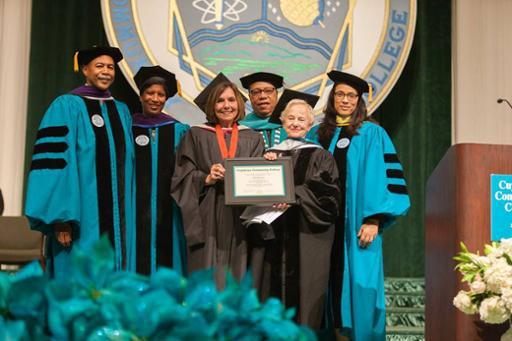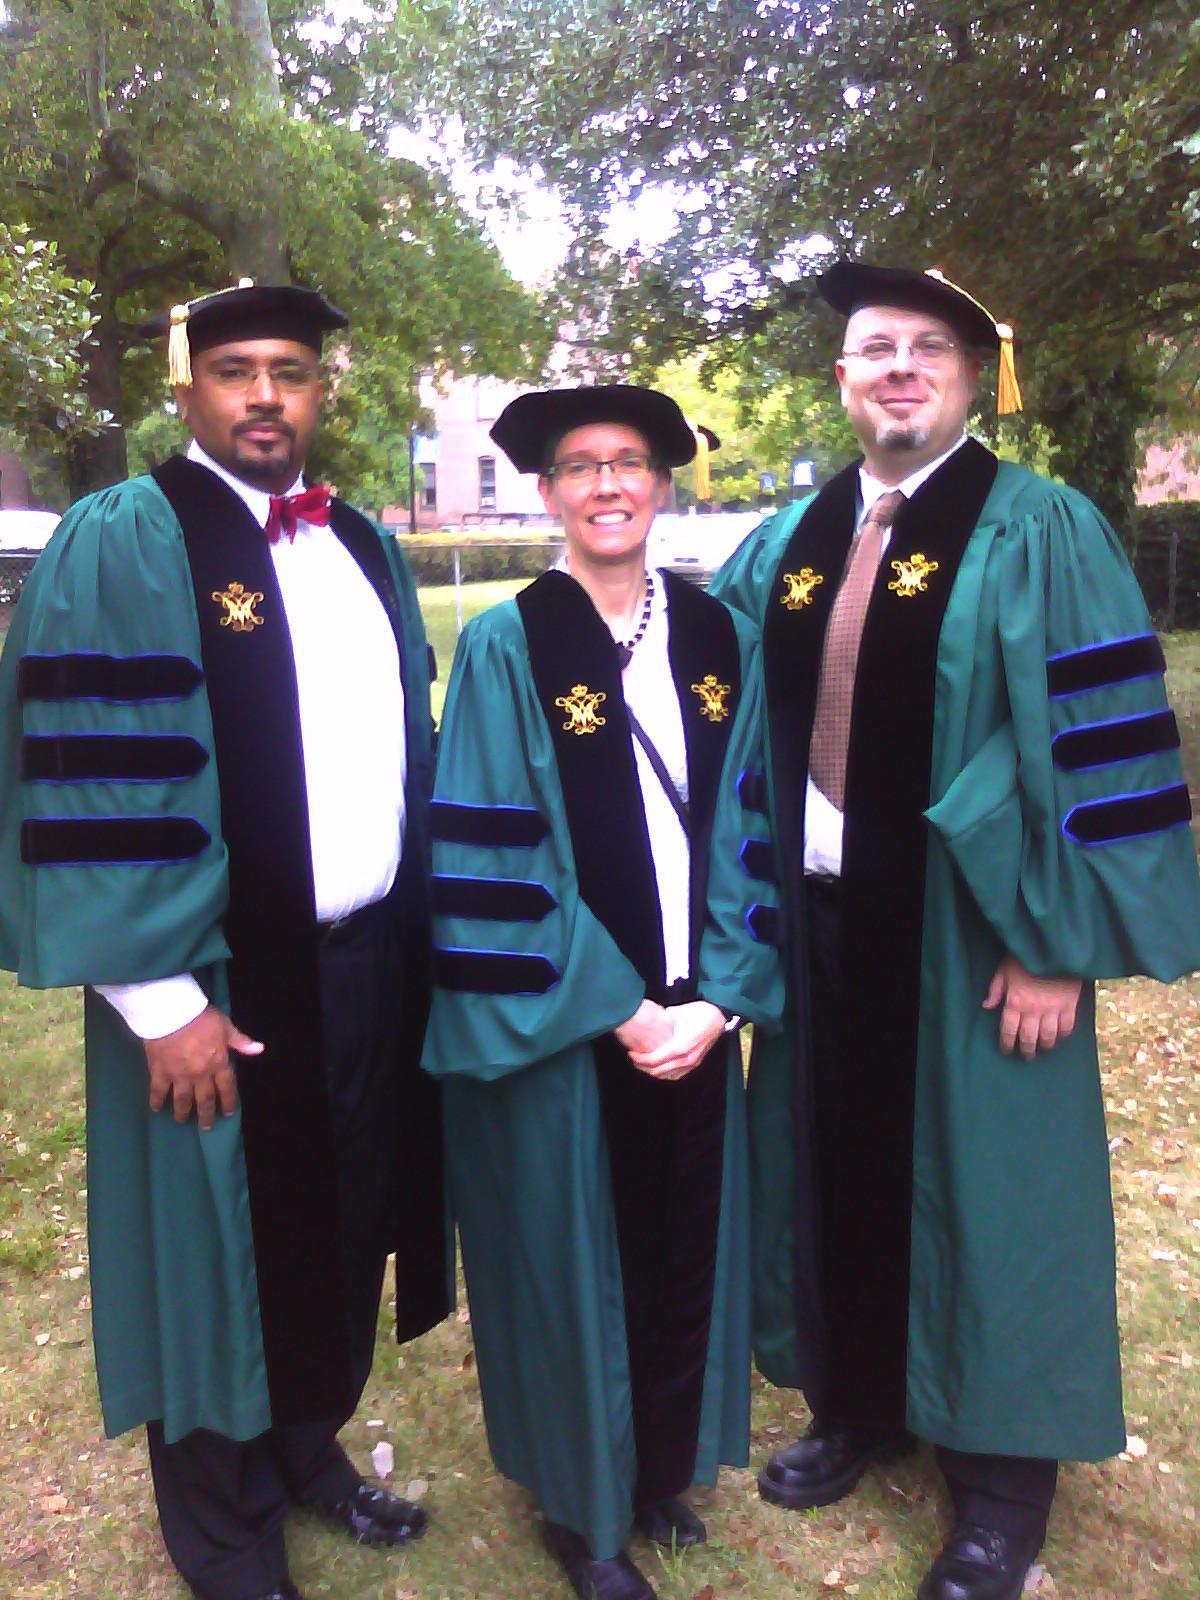The first image is the image on the left, the second image is the image on the right. Analyze the images presented: Is the assertion "There are 8 graduates in both images." valid? Answer yes or no. No. 